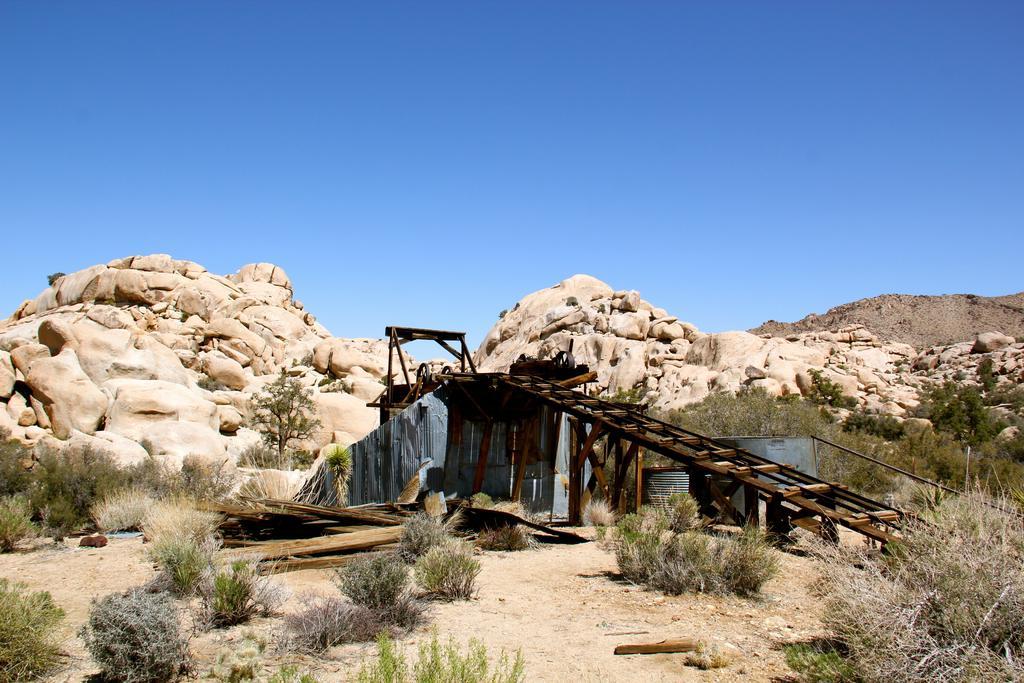How would you summarize this image in a sentence or two? In this image there is a wooden bridge surrounded with plants behind that there are some rock mountains. 